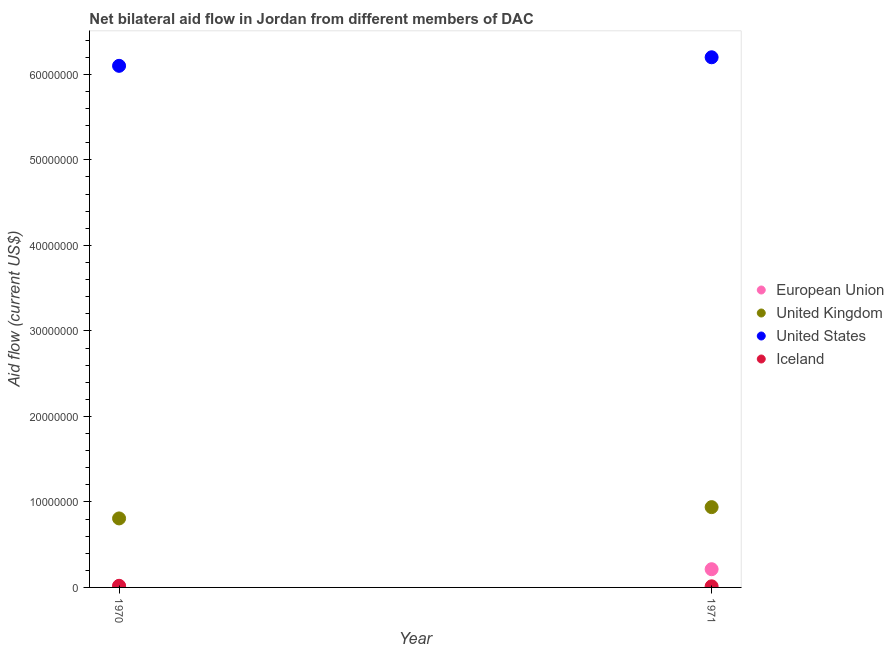What is the amount of aid given by iceland in 1971?
Keep it short and to the point. 1.30e+05. Across all years, what is the maximum amount of aid given by uk?
Provide a succinct answer. 9.39e+06. Across all years, what is the minimum amount of aid given by iceland?
Your response must be concise. 1.30e+05. In which year was the amount of aid given by eu maximum?
Ensure brevity in your answer.  1971. In which year was the amount of aid given by uk minimum?
Provide a short and direct response. 1970. What is the total amount of aid given by iceland in the graph?
Your answer should be very brief. 3.20e+05. What is the difference between the amount of aid given by uk in 1970 and that in 1971?
Offer a very short reply. -1.32e+06. What is the difference between the amount of aid given by iceland in 1970 and the amount of aid given by uk in 1971?
Offer a terse response. -9.20e+06. In the year 1971, what is the difference between the amount of aid given by eu and amount of aid given by iceland?
Ensure brevity in your answer.  2.00e+06. In how many years, is the amount of aid given by iceland greater than 14000000 US$?
Your answer should be very brief. 0. What is the ratio of the amount of aid given by iceland in 1970 to that in 1971?
Give a very brief answer. 1.46. Is it the case that in every year, the sum of the amount of aid given by eu and amount of aid given by uk is greater than the amount of aid given by us?
Make the answer very short. No. Does the amount of aid given by us monotonically increase over the years?
Your response must be concise. Yes. Is the amount of aid given by uk strictly greater than the amount of aid given by eu over the years?
Keep it short and to the point. Yes. How many dotlines are there?
Make the answer very short. 4. Are the values on the major ticks of Y-axis written in scientific E-notation?
Provide a short and direct response. No. Does the graph contain any zero values?
Keep it short and to the point. No. Where does the legend appear in the graph?
Ensure brevity in your answer.  Center right. How many legend labels are there?
Provide a short and direct response. 4. What is the title of the graph?
Keep it short and to the point. Net bilateral aid flow in Jordan from different members of DAC. Does "Periodicity assessment" appear as one of the legend labels in the graph?
Your response must be concise. No. What is the label or title of the X-axis?
Make the answer very short. Year. What is the label or title of the Y-axis?
Your answer should be very brief. Aid flow (current US$). What is the Aid flow (current US$) of United Kingdom in 1970?
Your answer should be compact. 8.07e+06. What is the Aid flow (current US$) of United States in 1970?
Your response must be concise. 6.10e+07. What is the Aid flow (current US$) of European Union in 1971?
Give a very brief answer. 2.13e+06. What is the Aid flow (current US$) of United Kingdom in 1971?
Your response must be concise. 9.39e+06. What is the Aid flow (current US$) of United States in 1971?
Your response must be concise. 6.20e+07. What is the Aid flow (current US$) of Iceland in 1971?
Your response must be concise. 1.30e+05. Across all years, what is the maximum Aid flow (current US$) of European Union?
Your answer should be compact. 2.13e+06. Across all years, what is the maximum Aid flow (current US$) of United Kingdom?
Offer a terse response. 9.39e+06. Across all years, what is the maximum Aid flow (current US$) of United States?
Keep it short and to the point. 6.20e+07. Across all years, what is the maximum Aid flow (current US$) in Iceland?
Offer a very short reply. 1.90e+05. Across all years, what is the minimum Aid flow (current US$) of European Union?
Offer a terse response. 1.20e+05. Across all years, what is the minimum Aid flow (current US$) in United Kingdom?
Offer a terse response. 8.07e+06. Across all years, what is the minimum Aid flow (current US$) in United States?
Your response must be concise. 6.10e+07. What is the total Aid flow (current US$) of European Union in the graph?
Make the answer very short. 2.25e+06. What is the total Aid flow (current US$) in United Kingdom in the graph?
Provide a short and direct response. 1.75e+07. What is the total Aid flow (current US$) in United States in the graph?
Provide a short and direct response. 1.23e+08. What is the difference between the Aid flow (current US$) in European Union in 1970 and that in 1971?
Your answer should be very brief. -2.01e+06. What is the difference between the Aid flow (current US$) of United Kingdom in 1970 and that in 1971?
Give a very brief answer. -1.32e+06. What is the difference between the Aid flow (current US$) of European Union in 1970 and the Aid flow (current US$) of United Kingdom in 1971?
Provide a short and direct response. -9.27e+06. What is the difference between the Aid flow (current US$) in European Union in 1970 and the Aid flow (current US$) in United States in 1971?
Offer a terse response. -6.19e+07. What is the difference between the Aid flow (current US$) of United Kingdom in 1970 and the Aid flow (current US$) of United States in 1971?
Ensure brevity in your answer.  -5.39e+07. What is the difference between the Aid flow (current US$) in United Kingdom in 1970 and the Aid flow (current US$) in Iceland in 1971?
Offer a terse response. 7.94e+06. What is the difference between the Aid flow (current US$) in United States in 1970 and the Aid flow (current US$) in Iceland in 1971?
Give a very brief answer. 6.09e+07. What is the average Aid flow (current US$) in European Union per year?
Provide a succinct answer. 1.12e+06. What is the average Aid flow (current US$) of United Kingdom per year?
Your answer should be very brief. 8.73e+06. What is the average Aid flow (current US$) of United States per year?
Provide a short and direct response. 6.15e+07. In the year 1970, what is the difference between the Aid flow (current US$) in European Union and Aid flow (current US$) in United Kingdom?
Your answer should be compact. -7.95e+06. In the year 1970, what is the difference between the Aid flow (current US$) in European Union and Aid flow (current US$) in United States?
Offer a very short reply. -6.09e+07. In the year 1970, what is the difference between the Aid flow (current US$) in European Union and Aid flow (current US$) in Iceland?
Your answer should be compact. -7.00e+04. In the year 1970, what is the difference between the Aid flow (current US$) of United Kingdom and Aid flow (current US$) of United States?
Provide a succinct answer. -5.29e+07. In the year 1970, what is the difference between the Aid flow (current US$) of United Kingdom and Aid flow (current US$) of Iceland?
Provide a succinct answer. 7.88e+06. In the year 1970, what is the difference between the Aid flow (current US$) in United States and Aid flow (current US$) in Iceland?
Ensure brevity in your answer.  6.08e+07. In the year 1971, what is the difference between the Aid flow (current US$) in European Union and Aid flow (current US$) in United Kingdom?
Offer a very short reply. -7.26e+06. In the year 1971, what is the difference between the Aid flow (current US$) of European Union and Aid flow (current US$) of United States?
Ensure brevity in your answer.  -5.99e+07. In the year 1971, what is the difference between the Aid flow (current US$) in European Union and Aid flow (current US$) in Iceland?
Provide a short and direct response. 2.00e+06. In the year 1971, what is the difference between the Aid flow (current US$) in United Kingdom and Aid flow (current US$) in United States?
Keep it short and to the point. -5.26e+07. In the year 1971, what is the difference between the Aid flow (current US$) of United Kingdom and Aid flow (current US$) of Iceland?
Provide a short and direct response. 9.26e+06. In the year 1971, what is the difference between the Aid flow (current US$) of United States and Aid flow (current US$) of Iceland?
Your response must be concise. 6.19e+07. What is the ratio of the Aid flow (current US$) in European Union in 1970 to that in 1971?
Your answer should be very brief. 0.06. What is the ratio of the Aid flow (current US$) in United Kingdom in 1970 to that in 1971?
Your answer should be compact. 0.86. What is the ratio of the Aid flow (current US$) of United States in 1970 to that in 1971?
Offer a terse response. 0.98. What is the ratio of the Aid flow (current US$) of Iceland in 1970 to that in 1971?
Your answer should be compact. 1.46. What is the difference between the highest and the second highest Aid flow (current US$) of European Union?
Your answer should be compact. 2.01e+06. What is the difference between the highest and the second highest Aid flow (current US$) of United Kingdom?
Your answer should be very brief. 1.32e+06. What is the difference between the highest and the second highest Aid flow (current US$) of Iceland?
Your answer should be very brief. 6.00e+04. What is the difference between the highest and the lowest Aid flow (current US$) of European Union?
Offer a terse response. 2.01e+06. What is the difference between the highest and the lowest Aid flow (current US$) of United Kingdom?
Give a very brief answer. 1.32e+06. What is the difference between the highest and the lowest Aid flow (current US$) of Iceland?
Ensure brevity in your answer.  6.00e+04. 